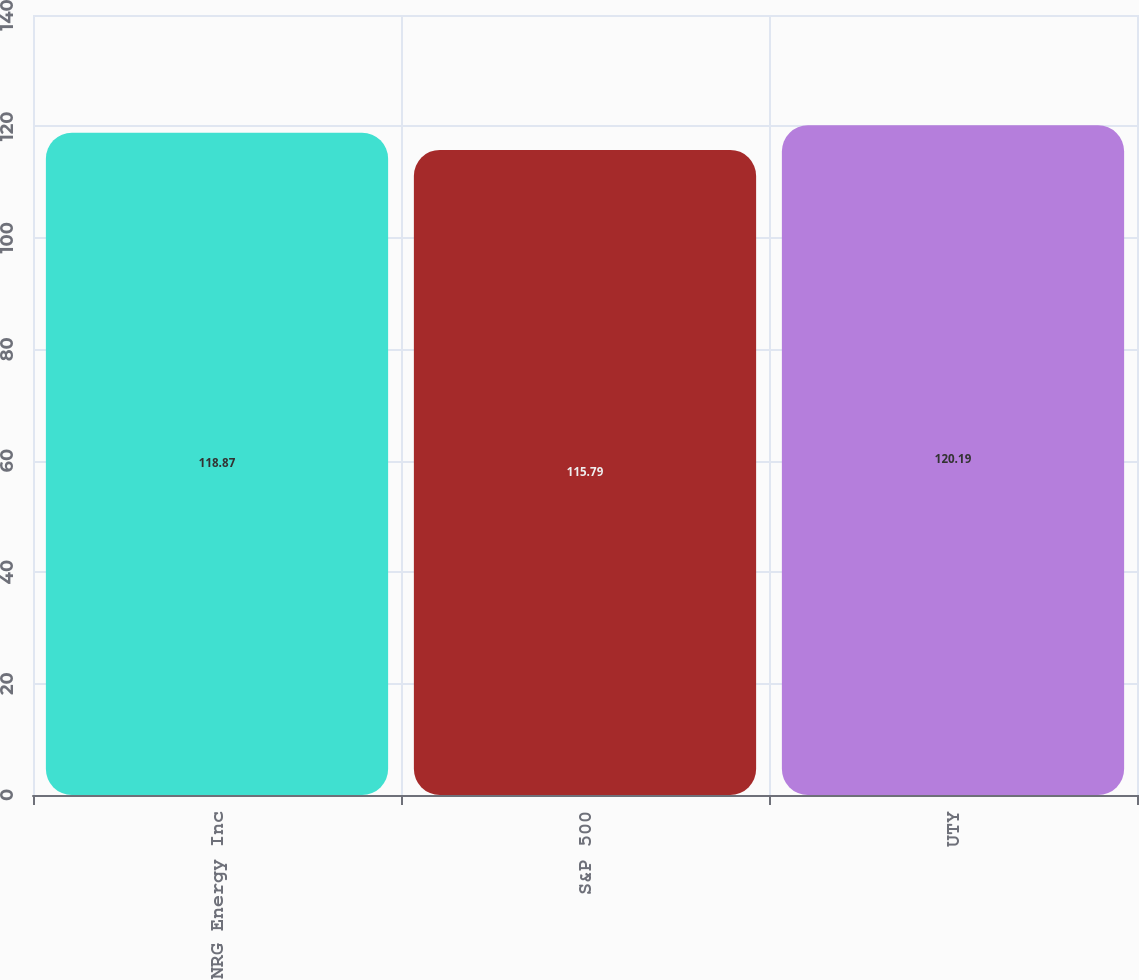Convert chart to OTSL. <chart><loc_0><loc_0><loc_500><loc_500><bar_chart><fcel>NRG Energy Inc<fcel>S&P 500<fcel>UTY<nl><fcel>118.87<fcel>115.79<fcel>120.19<nl></chart> 